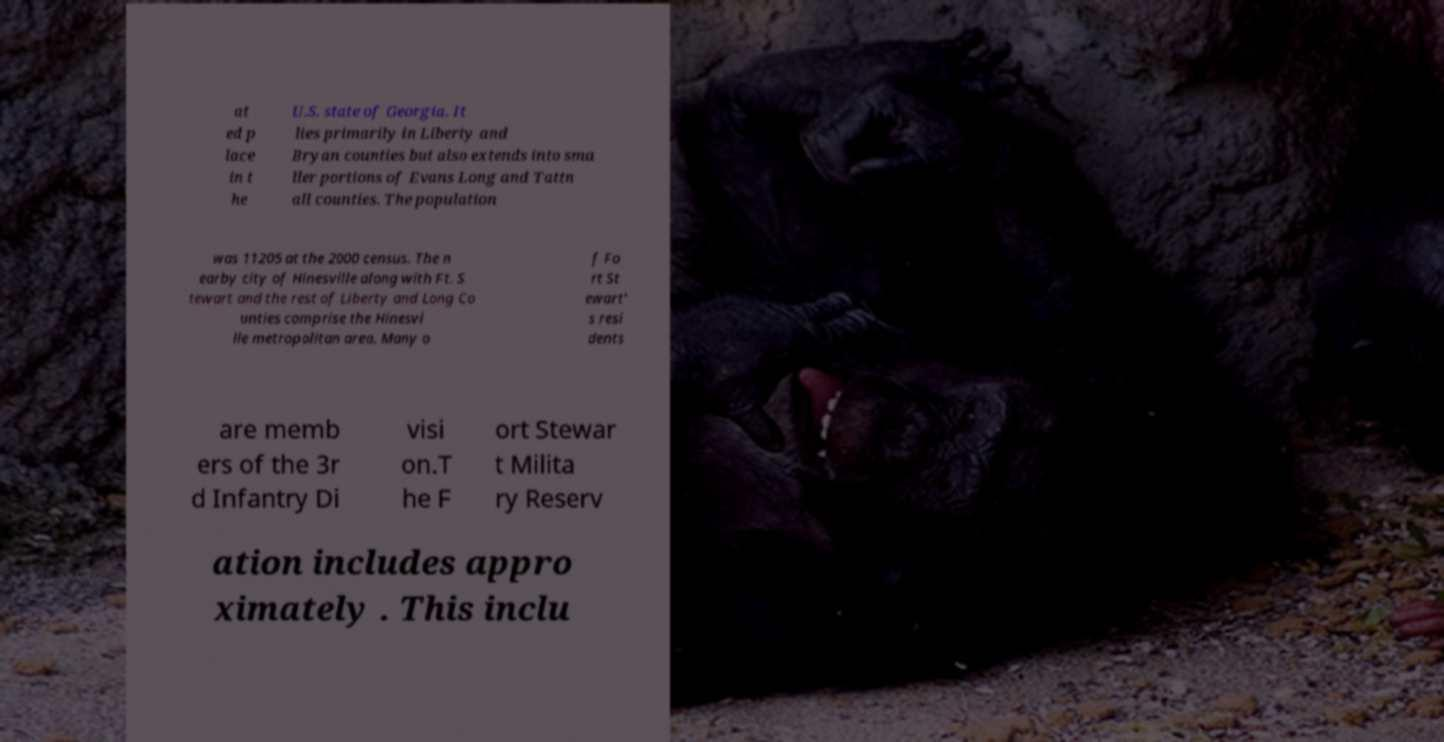Please identify and transcribe the text found in this image. at ed p lace in t he U.S. state of Georgia. It lies primarily in Liberty and Bryan counties but also extends into sma ller portions of Evans Long and Tattn all counties. The population was 11205 at the 2000 census. The n earby city of Hinesville along with Ft. S tewart and the rest of Liberty and Long Co unties comprise the Hinesvi lle metropolitan area. Many o f Fo rt St ewart' s resi dents are memb ers of the 3r d Infantry Di visi on.T he F ort Stewar t Milita ry Reserv ation includes appro ximately . This inclu 